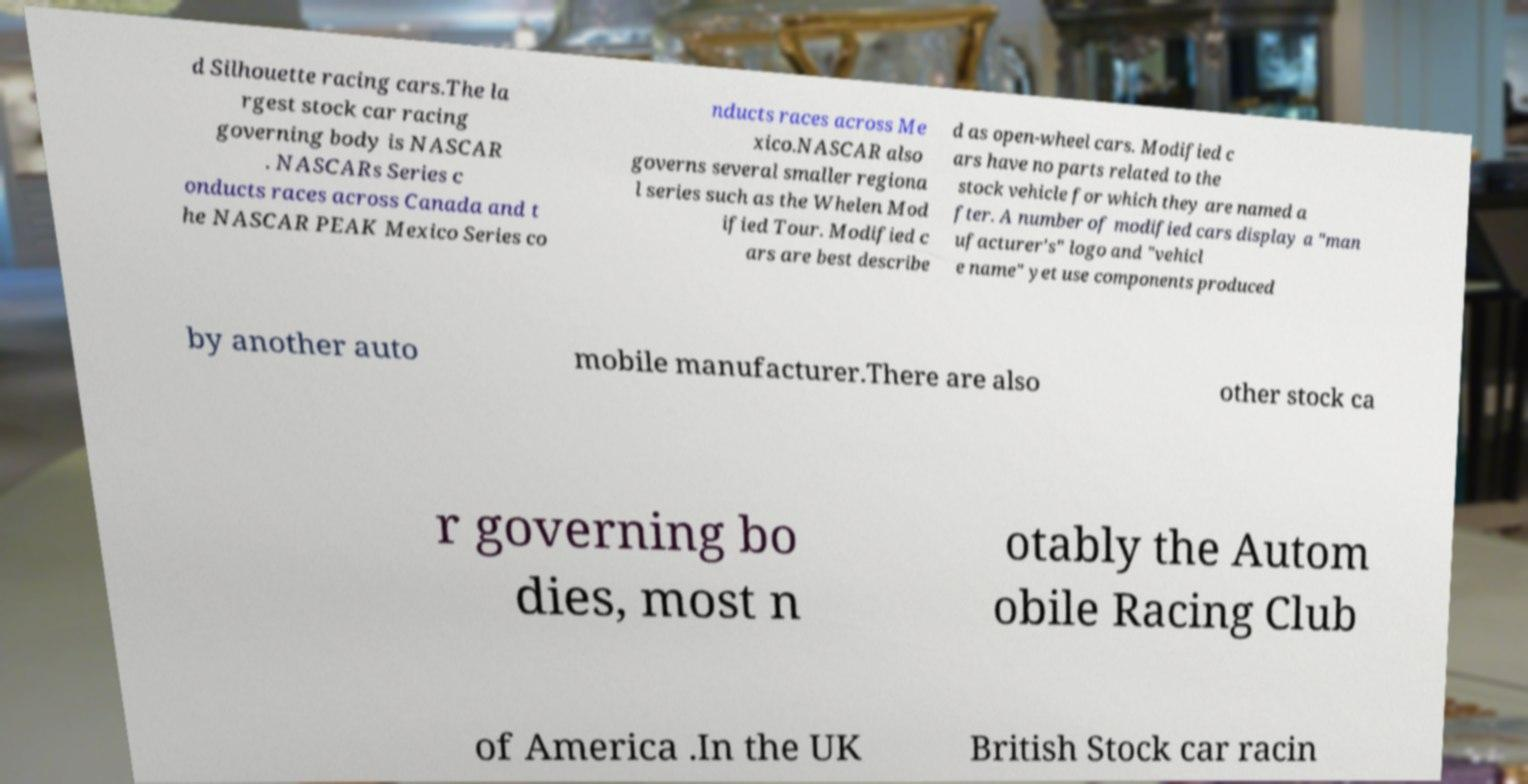Can you accurately transcribe the text from the provided image for me? d Silhouette racing cars.The la rgest stock car racing governing body is NASCAR . NASCARs Series c onducts races across Canada and t he NASCAR PEAK Mexico Series co nducts races across Me xico.NASCAR also governs several smaller regiona l series such as the Whelen Mod ified Tour. Modified c ars are best describe d as open-wheel cars. Modified c ars have no parts related to the stock vehicle for which they are named a fter. A number of modified cars display a "man ufacturer's" logo and "vehicl e name" yet use components produced by another auto mobile manufacturer.There are also other stock ca r governing bo dies, most n otably the Autom obile Racing Club of America .In the UK British Stock car racin 